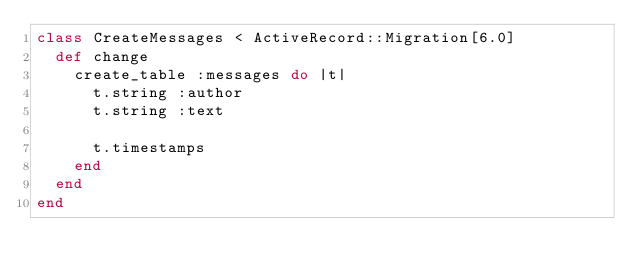<code> <loc_0><loc_0><loc_500><loc_500><_Ruby_>class CreateMessages < ActiveRecord::Migration[6.0]
  def change
    create_table :messages do |t|
      t.string :author
      t.string :text

      t.timestamps
    end
  end
end
</code> 